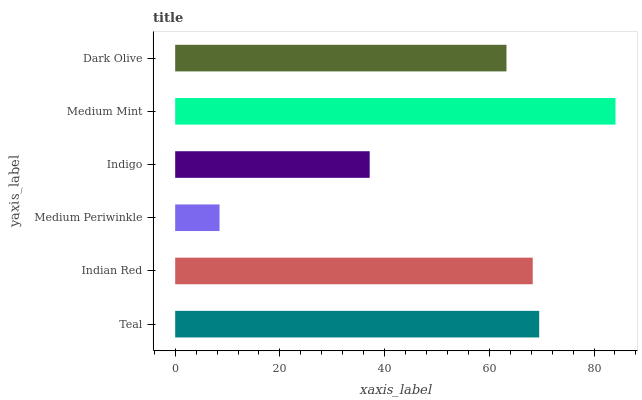Is Medium Periwinkle the minimum?
Answer yes or no. Yes. Is Medium Mint the maximum?
Answer yes or no. Yes. Is Indian Red the minimum?
Answer yes or no. No. Is Indian Red the maximum?
Answer yes or no. No. Is Teal greater than Indian Red?
Answer yes or no. Yes. Is Indian Red less than Teal?
Answer yes or no. Yes. Is Indian Red greater than Teal?
Answer yes or no. No. Is Teal less than Indian Red?
Answer yes or no. No. Is Indian Red the high median?
Answer yes or no. Yes. Is Dark Olive the low median?
Answer yes or no. Yes. Is Medium Mint the high median?
Answer yes or no. No. Is Medium Mint the low median?
Answer yes or no. No. 